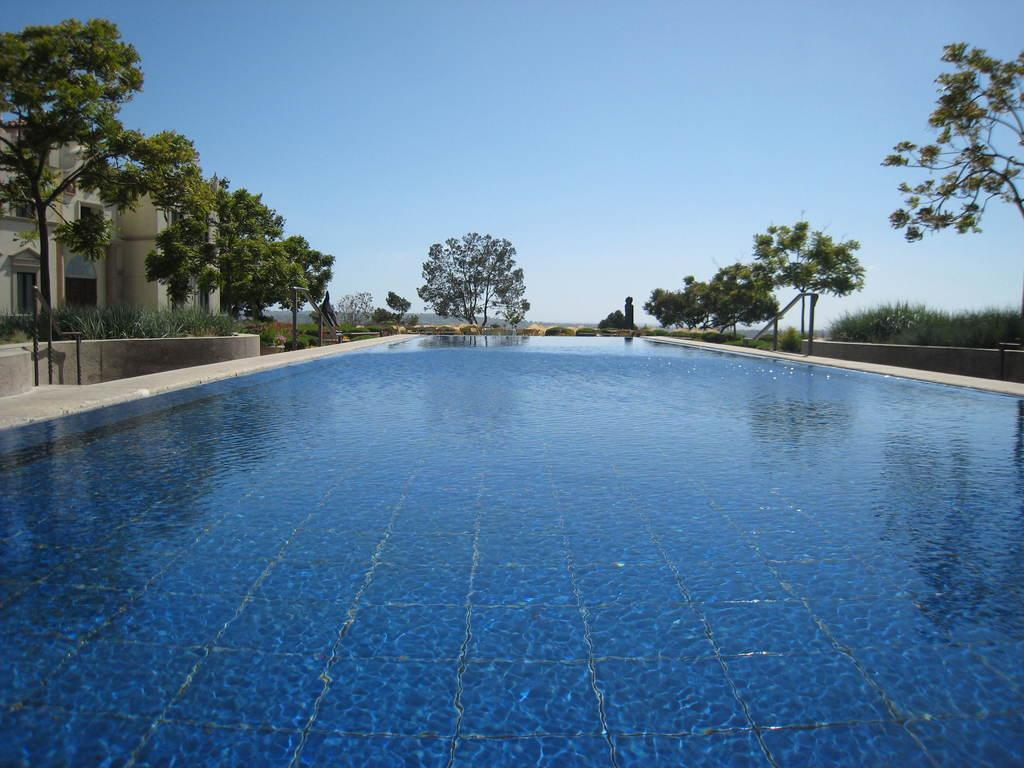What type of natural feature is present in the image? There is a water body in the image. What man-made structures can be seen in the image? There are metal poles and a building with windows in the image. What type of vegetation is present in the image? There are plants and a group of trees in the image. What is visible in the sky in the image? The sky is visible in the image and appears cloudy. How many eggs are being carried by the cow in the image? There is no cow or eggs present in the image. What type of stranger can be seen interacting with the group of trees in the image? There is no stranger present in the image; only the water body, metal poles, building, plants, and trees are visible. 